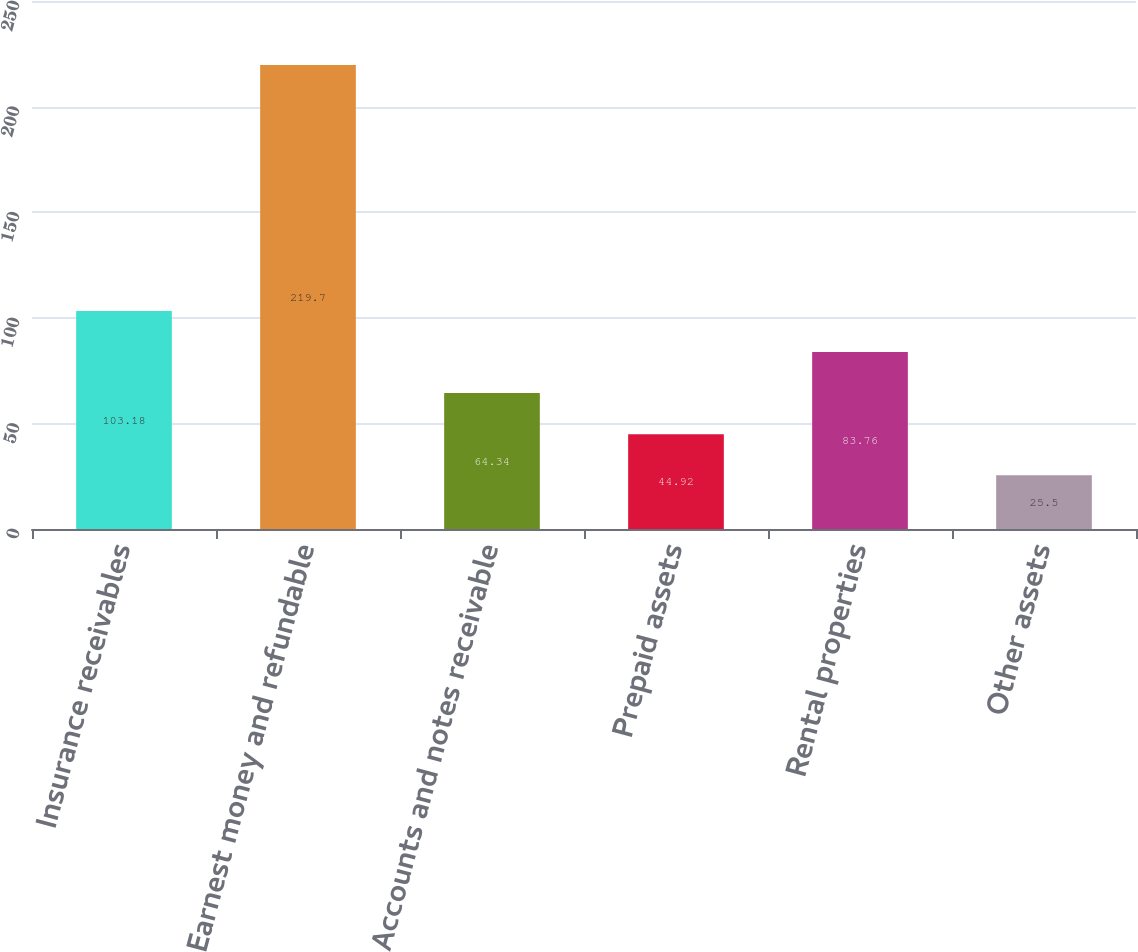Convert chart. <chart><loc_0><loc_0><loc_500><loc_500><bar_chart><fcel>Insurance receivables<fcel>Earnest money and refundable<fcel>Accounts and notes receivable<fcel>Prepaid assets<fcel>Rental properties<fcel>Other assets<nl><fcel>103.18<fcel>219.7<fcel>64.34<fcel>44.92<fcel>83.76<fcel>25.5<nl></chart> 